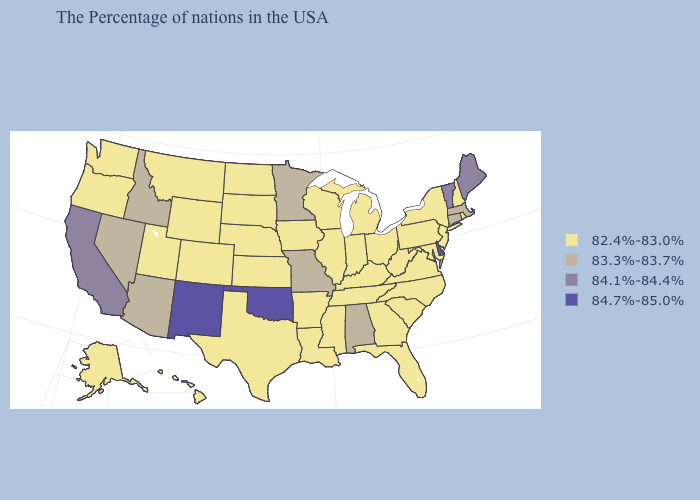Name the states that have a value in the range 84.7%-85.0%?
Answer briefly. Delaware, Oklahoma, New Mexico. What is the value of Texas?
Concise answer only. 82.4%-83.0%. What is the value of Oklahoma?
Write a very short answer. 84.7%-85.0%. What is the lowest value in states that border Iowa?
Quick response, please. 82.4%-83.0%. Which states hav the highest value in the Northeast?
Short answer required. Maine, Vermont. Name the states that have a value in the range 83.3%-83.7%?
Keep it brief. Massachusetts, Connecticut, Alabama, Missouri, Minnesota, Arizona, Idaho, Nevada. How many symbols are there in the legend?
Concise answer only. 4. Name the states that have a value in the range 83.3%-83.7%?
Give a very brief answer. Massachusetts, Connecticut, Alabama, Missouri, Minnesota, Arizona, Idaho, Nevada. Which states have the highest value in the USA?
Be succinct. Delaware, Oklahoma, New Mexico. Name the states that have a value in the range 83.3%-83.7%?
Give a very brief answer. Massachusetts, Connecticut, Alabama, Missouri, Minnesota, Arizona, Idaho, Nevada. What is the highest value in states that border Delaware?
Write a very short answer. 82.4%-83.0%. What is the highest value in the USA?
Short answer required. 84.7%-85.0%. Does New York have a higher value than Maryland?
Quick response, please. No. How many symbols are there in the legend?
Keep it brief. 4. Among the states that border North Carolina , which have the lowest value?
Concise answer only. Virginia, South Carolina, Georgia, Tennessee. 